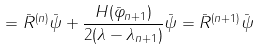<formula> <loc_0><loc_0><loc_500><loc_500>= \bar { R } ^ { ( n ) } \bar { \psi } + \frac { H ( \bar { \varphi } _ { n + 1 } ) } { 2 ( \lambda - \lambda _ { n + 1 } ) } \bar { \psi } = \bar { R } ^ { ( n + 1 ) } \bar { \psi }</formula> 